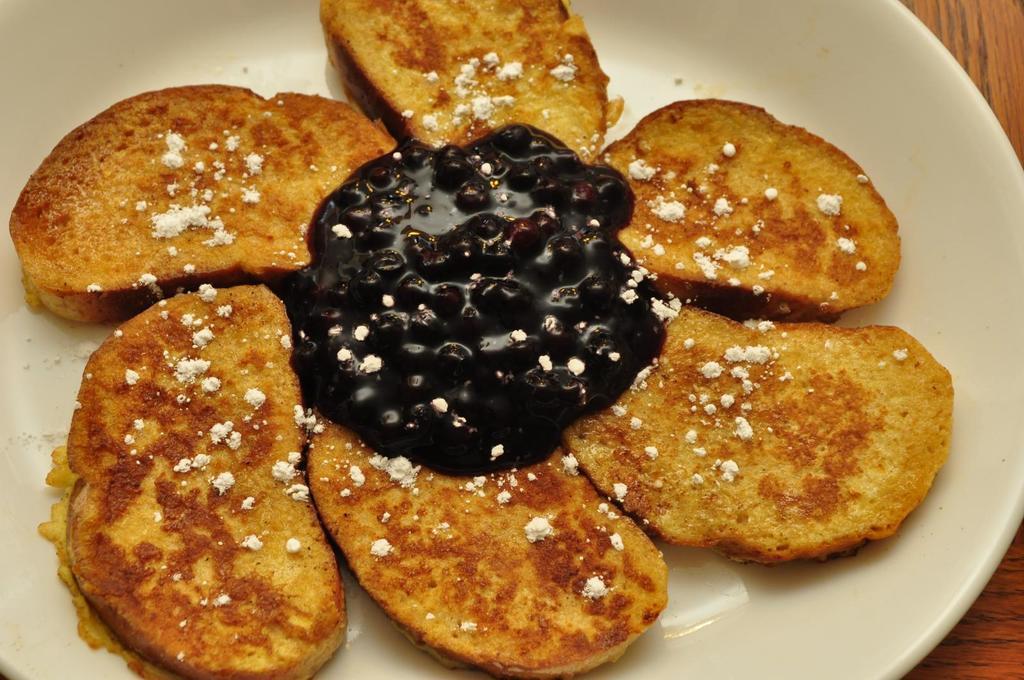Can you describe this image briefly? In this image I can see a plate in which toast and fruit jam is there kept on the table. This image is taken may be in a room. 